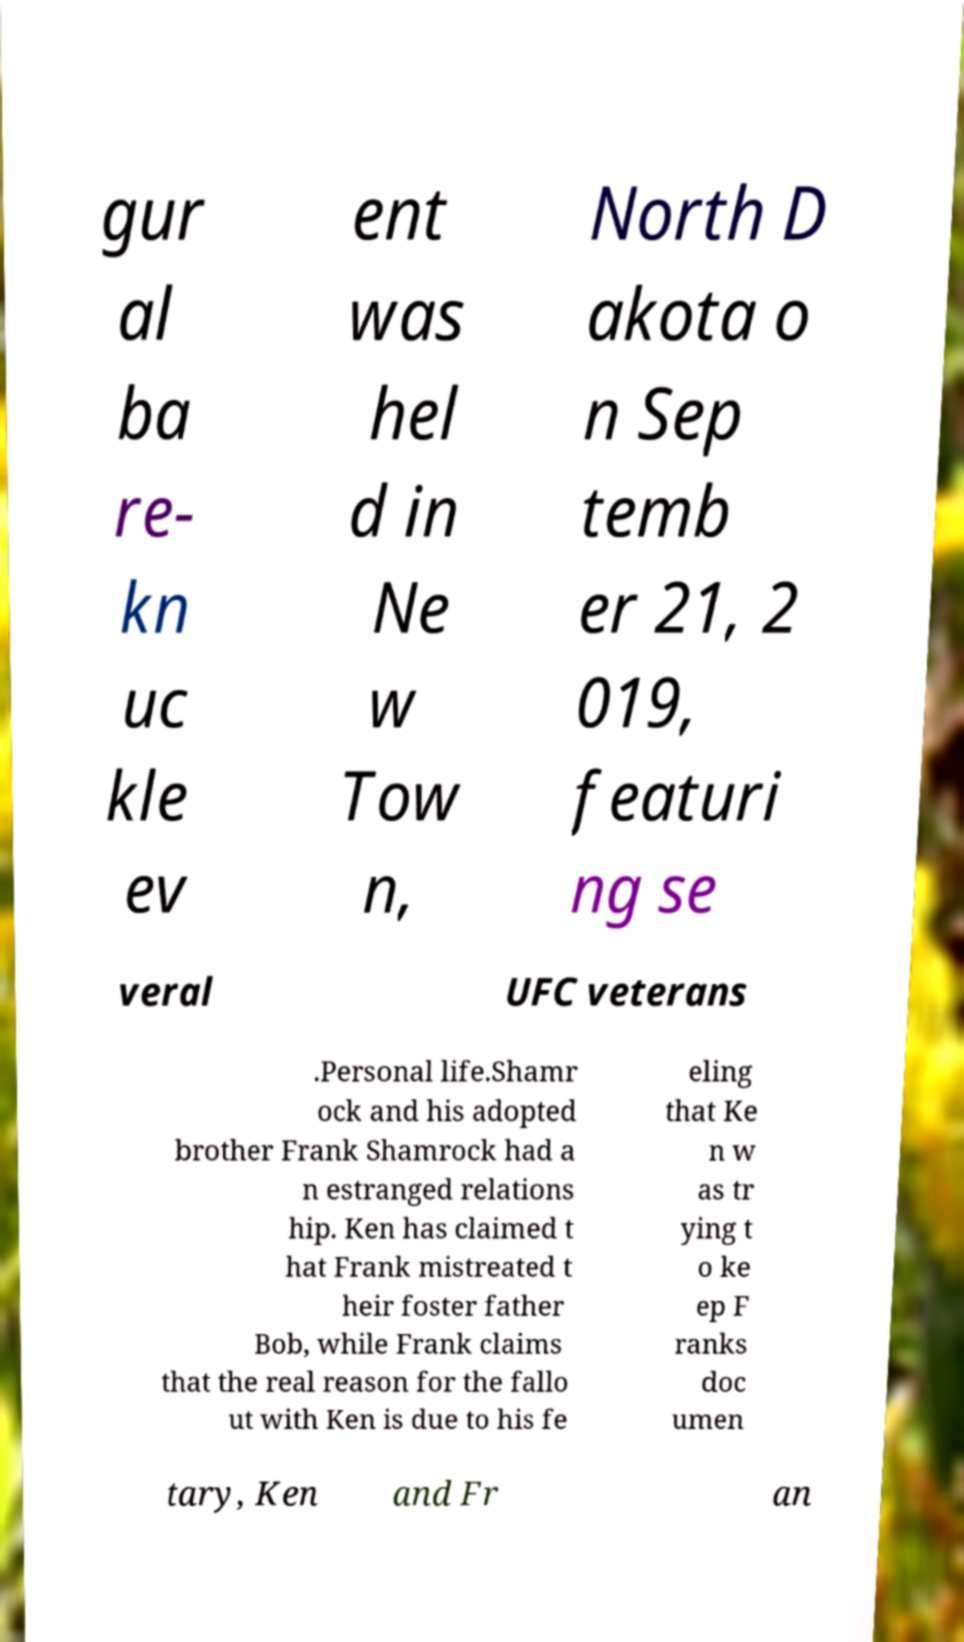Can you accurately transcribe the text from the provided image for me? gur al ba re- kn uc kle ev ent was hel d in Ne w Tow n, North D akota o n Sep temb er 21, 2 019, featuri ng se veral UFC veterans .Personal life.Shamr ock and his adopted brother Frank Shamrock had a n estranged relations hip. Ken has claimed t hat Frank mistreated t heir foster father Bob, while Frank claims that the real reason for the fallo ut with Ken is due to his fe eling that Ke n w as tr ying t o ke ep F ranks doc umen tary, Ken and Fr an 